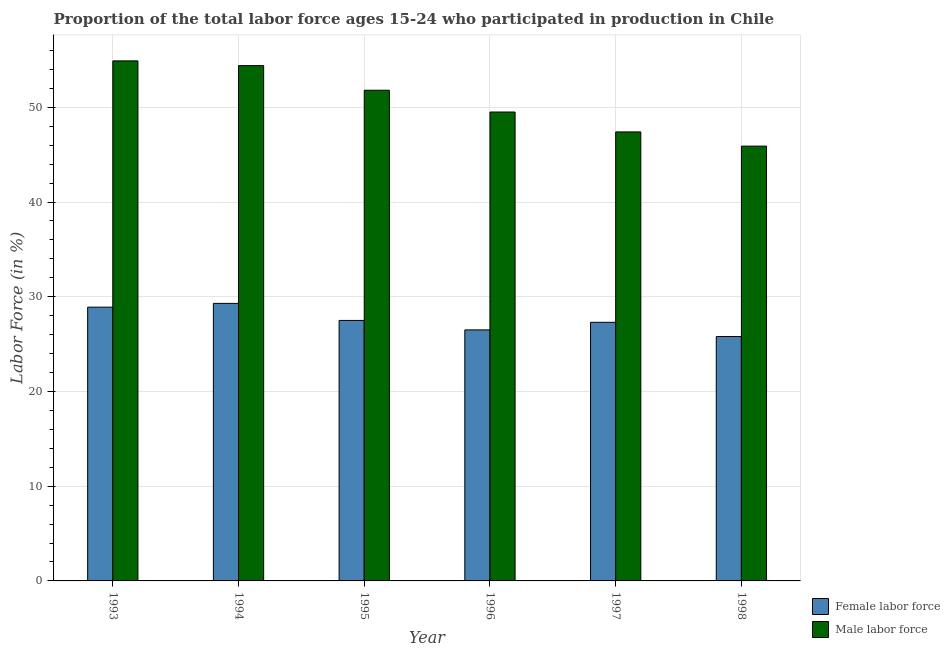How many different coloured bars are there?
Provide a short and direct response. 2. How many groups of bars are there?
Provide a short and direct response. 6. Are the number of bars on each tick of the X-axis equal?
Offer a very short reply. Yes. How many bars are there on the 3rd tick from the left?
Provide a succinct answer. 2. What is the percentage of male labour force in 1998?
Provide a short and direct response. 45.9. Across all years, what is the maximum percentage of male labour force?
Ensure brevity in your answer.  54.9. Across all years, what is the minimum percentage of female labor force?
Your response must be concise. 25.8. In which year was the percentage of female labor force maximum?
Give a very brief answer. 1994. In which year was the percentage of female labor force minimum?
Provide a succinct answer. 1998. What is the total percentage of female labor force in the graph?
Your answer should be very brief. 165.3. What is the difference between the percentage of female labor force in 1994 and that in 1995?
Offer a terse response. 1.8. What is the difference between the percentage of male labour force in 1996 and the percentage of female labor force in 1994?
Provide a short and direct response. -4.9. What is the average percentage of female labor force per year?
Ensure brevity in your answer.  27.55. In the year 1996, what is the difference between the percentage of female labor force and percentage of male labour force?
Your answer should be compact. 0. In how many years, is the percentage of female labor force greater than 10 %?
Your answer should be very brief. 6. What is the ratio of the percentage of female labor force in 1994 to that in 1998?
Offer a terse response. 1.14. What is the difference between the highest and the second highest percentage of female labor force?
Offer a very short reply. 0.4. What is the difference between the highest and the lowest percentage of male labour force?
Make the answer very short. 9. What does the 1st bar from the left in 1993 represents?
Your answer should be compact. Female labor force. What does the 1st bar from the right in 1995 represents?
Your response must be concise. Male labor force. How many bars are there?
Your answer should be very brief. 12. Are all the bars in the graph horizontal?
Your answer should be very brief. No. How many years are there in the graph?
Keep it short and to the point. 6. Are the values on the major ticks of Y-axis written in scientific E-notation?
Your answer should be very brief. No. Does the graph contain any zero values?
Make the answer very short. No. Does the graph contain grids?
Make the answer very short. Yes. Where does the legend appear in the graph?
Make the answer very short. Bottom right. How are the legend labels stacked?
Offer a very short reply. Vertical. What is the title of the graph?
Provide a short and direct response. Proportion of the total labor force ages 15-24 who participated in production in Chile. Does "Official aid received" appear as one of the legend labels in the graph?
Provide a short and direct response. No. What is the label or title of the X-axis?
Provide a short and direct response. Year. What is the Labor Force (in %) of Female labor force in 1993?
Offer a terse response. 28.9. What is the Labor Force (in %) in Male labor force in 1993?
Your answer should be compact. 54.9. What is the Labor Force (in %) of Female labor force in 1994?
Provide a succinct answer. 29.3. What is the Labor Force (in %) in Male labor force in 1994?
Provide a short and direct response. 54.4. What is the Labor Force (in %) of Female labor force in 1995?
Offer a very short reply. 27.5. What is the Labor Force (in %) in Male labor force in 1995?
Offer a very short reply. 51.8. What is the Labor Force (in %) of Female labor force in 1996?
Make the answer very short. 26.5. What is the Labor Force (in %) in Male labor force in 1996?
Give a very brief answer. 49.5. What is the Labor Force (in %) in Female labor force in 1997?
Ensure brevity in your answer.  27.3. What is the Labor Force (in %) in Male labor force in 1997?
Your response must be concise. 47.4. What is the Labor Force (in %) in Female labor force in 1998?
Provide a short and direct response. 25.8. What is the Labor Force (in %) in Male labor force in 1998?
Offer a terse response. 45.9. Across all years, what is the maximum Labor Force (in %) in Female labor force?
Keep it short and to the point. 29.3. Across all years, what is the maximum Labor Force (in %) in Male labor force?
Your answer should be compact. 54.9. Across all years, what is the minimum Labor Force (in %) in Female labor force?
Offer a terse response. 25.8. Across all years, what is the minimum Labor Force (in %) in Male labor force?
Your answer should be compact. 45.9. What is the total Labor Force (in %) of Female labor force in the graph?
Provide a short and direct response. 165.3. What is the total Labor Force (in %) in Male labor force in the graph?
Give a very brief answer. 303.9. What is the difference between the Labor Force (in %) of Male labor force in 1993 and that in 1995?
Your answer should be very brief. 3.1. What is the difference between the Labor Force (in %) of Female labor force in 1993 and that in 1996?
Make the answer very short. 2.4. What is the difference between the Labor Force (in %) of Male labor force in 1993 and that in 1996?
Offer a terse response. 5.4. What is the difference between the Labor Force (in %) of Female labor force in 1993 and that in 1997?
Ensure brevity in your answer.  1.6. What is the difference between the Labor Force (in %) of Female labor force in 1993 and that in 1998?
Offer a terse response. 3.1. What is the difference between the Labor Force (in %) of Male labor force in 1993 and that in 1998?
Your response must be concise. 9. What is the difference between the Labor Force (in %) of Male labor force in 1994 and that in 1995?
Offer a terse response. 2.6. What is the difference between the Labor Force (in %) of Female labor force in 1994 and that in 1996?
Your response must be concise. 2.8. What is the difference between the Labor Force (in %) of Male labor force in 1994 and that in 1996?
Your response must be concise. 4.9. What is the difference between the Labor Force (in %) of Female labor force in 1994 and that in 1998?
Offer a terse response. 3.5. What is the difference between the Labor Force (in %) of Male labor force in 1994 and that in 1998?
Ensure brevity in your answer.  8.5. What is the difference between the Labor Force (in %) in Male labor force in 1995 and that in 1996?
Offer a very short reply. 2.3. What is the difference between the Labor Force (in %) in Male labor force in 1995 and that in 1997?
Provide a succinct answer. 4.4. What is the difference between the Labor Force (in %) of Male labor force in 1995 and that in 1998?
Provide a succinct answer. 5.9. What is the difference between the Labor Force (in %) in Female labor force in 1996 and that in 1997?
Your answer should be compact. -0.8. What is the difference between the Labor Force (in %) of Male labor force in 1996 and that in 1997?
Your answer should be compact. 2.1. What is the difference between the Labor Force (in %) of Female labor force in 1997 and that in 1998?
Offer a very short reply. 1.5. What is the difference between the Labor Force (in %) in Male labor force in 1997 and that in 1998?
Keep it short and to the point. 1.5. What is the difference between the Labor Force (in %) in Female labor force in 1993 and the Labor Force (in %) in Male labor force in 1994?
Offer a terse response. -25.5. What is the difference between the Labor Force (in %) in Female labor force in 1993 and the Labor Force (in %) in Male labor force in 1995?
Offer a very short reply. -22.9. What is the difference between the Labor Force (in %) of Female labor force in 1993 and the Labor Force (in %) of Male labor force in 1996?
Your response must be concise. -20.6. What is the difference between the Labor Force (in %) in Female labor force in 1993 and the Labor Force (in %) in Male labor force in 1997?
Offer a terse response. -18.5. What is the difference between the Labor Force (in %) of Female labor force in 1994 and the Labor Force (in %) of Male labor force in 1995?
Make the answer very short. -22.5. What is the difference between the Labor Force (in %) in Female labor force in 1994 and the Labor Force (in %) in Male labor force in 1996?
Make the answer very short. -20.2. What is the difference between the Labor Force (in %) of Female labor force in 1994 and the Labor Force (in %) of Male labor force in 1997?
Your answer should be compact. -18.1. What is the difference between the Labor Force (in %) of Female labor force in 1994 and the Labor Force (in %) of Male labor force in 1998?
Make the answer very short. -16.6. What is the difference between the Labor Force (in %) in Female labor force in 1995 and the Labor Force (in %) in Male labor force in 1997?
Offer a very short reply. -19.9. What is the difference between the Labor Force (in %) of Female labor force in 1995 and the Labor Force (in %) of Male labor force in 1998?
Your answer should be compact. -18.4. What is the difference between the Labor Force (in %) in Female labor force in 1996 and the Labor Force (in %) in Male labor force in 1997?
Ensure brevity in your answer.  -20.9. What is the difference between the Labor Force (in %) in Female labor force in 1996 and the Labor Force (in %) in Male labor force in 1998?
Provide a succinct answer. -19.4. What is the difference between the Labor Force (in %) of Female labor force in 1997 and the Labor Force (in %) of Male labor force in 1998?
Provide a short and direct response. -18.6. What is the average Labor Force (in %) in Female labor force per year?
Provide a short and direct response. 27.55. What is the average Labor Force (in %) in Male labor force per year?
Provide a succinct answer. 50.65. In the year 1993, what is the difference between the Labor Force (in %) of Female labor force and Labor Force (in %) of Male labor force?
Give a very brief answer. -26. In the year 1994, what is the difference between the Labor Force (in %) of Female labor force and Labor Force (in %) of Male labor force?
Give a very brief answer. -25.1. In the year 1995, what is the difference between the Labor Force (in %) of Female labor force and Labor Force (in %) of Male labor force?
Your response must be concise. -24.3. In the year 1997, what is the difference between the Labor Force (in %) of Female labor force and Labor Force (in %) of Male labor force?
Keep it short and to the point. -20.1. In the year 1998, what is the difference between the Labor Force (in %) of Female labor force and Labor Force (in %) of Male labor force?
Keep it short and to the point. -20.1. What is the ratio of the Labor Force (in %) of Female labor force in 1993 to that in 1994?
Your response must be concise. 0.99. What is the ratio of the Labor Force (in %) of Male labor force in 1993 to that in 1994?
Ensure brevity in your answer.  1.01. What is the ratio of the Labor Force (in %) of Female labor force in 1993 to that in 1995?
Your answer should be very brief. 1.05. What is the ratio of the Labor Force (in %) of Male labor force in 1993 to that in 1995?
Offer a very short reply. 1.06. What is the ratio of the Labor Force (in %) of Female labor force in 1993 to that in 1996?
Make the answer very short. 1.09. What is the ratio of the Labor Force (in %) of Male labor force in 1993 to that in 1996?
Ensure brevity in your answer.  1.11. What is the ratio of the Labor Force (in %) in Female labor force in 1993 to that in 1997?
Keep it short and to the point. 1.06. What is the ratio of the Labor Force (in %) in Male labor force in 1993 to that in 1997?
Your response must be concise. 1.16. What is the ratio of the Labor Force (in %) in Female labor force in 1993 to that in 1998?
Your response must be concise. 1.12. What is the ratio of the Labor Force (in %) in Male labor force in 1993 to that in 1998?
Offer a very short reply. 1.2. What is the ratio of the Labor Force (in %) in Female labor force in 1994 to that in 1995?
Ensure brevity in your answer.  1.07. What is the ratio of the Labor Force (in %) in Male labor force in 1994 to that in 1995?
Provide a succinct answer. 1.05. What is the ratio of the Labor Force (in %) of Female labor force in 1994 to that in 1996?
Your answer should be compact. 1.11. What is the ratio of the Labor Force (in %) of Male labor force in 1994 to that in 1996?
Your response must be concise. 1.1. What is the ratio of the Labor Force (in %) in Female labor force in 1994 to that in 1997?
Provide a short and direct response. 1.07. What is the ratio of the Labor Force (in %) in Male labor force in 1994 to that in 1997?
Your answer should be compact. 1.15. What is the ratio of the Labor Force (in %) of Female labor force in 1994 to that in 1998?
Your answer should be very brief. 1.14. What is the ratio of the Labor Force (in %) of Male labor force in 1994 to that in 1998?
Ensure brevity in your answer.  1.19. What is the ratio of the Labor Force (in %) of Female labor force in 1995 to that in 1996?
Give a very brief answer. 1.04. What is the ratio of the Labor Force (in %) of Male labor force in 1995 to that in 1996?
Keep it short and to the point. 1.05. What is the ratio of the Labor Force (in %) in Female labor force in 1995 to that in 1997?
Offer a terse response. 1.01. What is the ratio of the Labor Force (in %) in Male labor force in 1995 to that in 1997?
Keep it short and to the point. 1.09. What is the ratio of the Labor Force (in %) in Female labor force in 1995 to that in 1998?
Keep it short and to the point. 1.07. What is the ratio of the Labor Force (in %) in Male labor force in 1995 to that in 1998?
Provide a short and direct response. 1.13. What is the ratio of the Labor Force (in %) of Female labor force in 1996 to that in 1997?
Make the answer very short. 0.97. What is the ratio of the Labor Force (in %) of Male labor force in 1996 to that in 1997?
Your answer should be very brief. 1.04. What is the ratio of the Labor Force (in %) of Female labor force in 1996 to that in 1998?
Give a very brief answer. 1.03. What is the ratio of the Labor Force (in %) of Male labor force in 1996 to that in 1998?
Offer a very short reply. 1.08. What is the ratio of the Labor Force (in %) of Female labor force in 1997 to that in 1998?
Your answer should be very brief. 1.06. What is the ratio of the Labor Force (in %) in Male labor force in 1997 to that in 1998?
Keep it short and to the point. 1.03. What is the difference between the highest and the second highest Labor Force (in %) of Male labor force?
Provide a short and direct response. 0.5. What is the difference between the highest and the lowest Labor Force (in %) of Female labor force?
Make the answer very short. 3.5. 